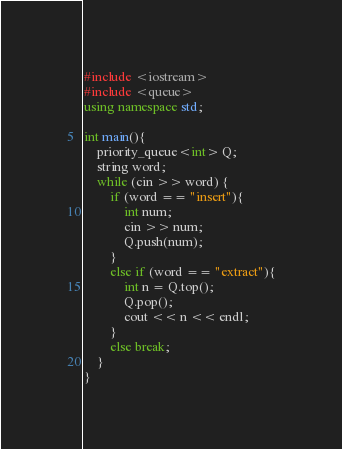Convert code to text. <code><loc_0><loc_0><loc_500><loc_500><_C++_>#include <iostream>
#include <queue>
using namespace std;

int main(){
	priority_queue<int> Q;
	string word;
	while (cin >> word) {		
		if (word == "insert"){
			int num;
			cin >> num;
			Q.push(num);
		}
		else if (word == "extract"){
			int n = Q.top();
			Q.pop();
			cout << n << endl;
		}
		else break;
	}
}</code> 